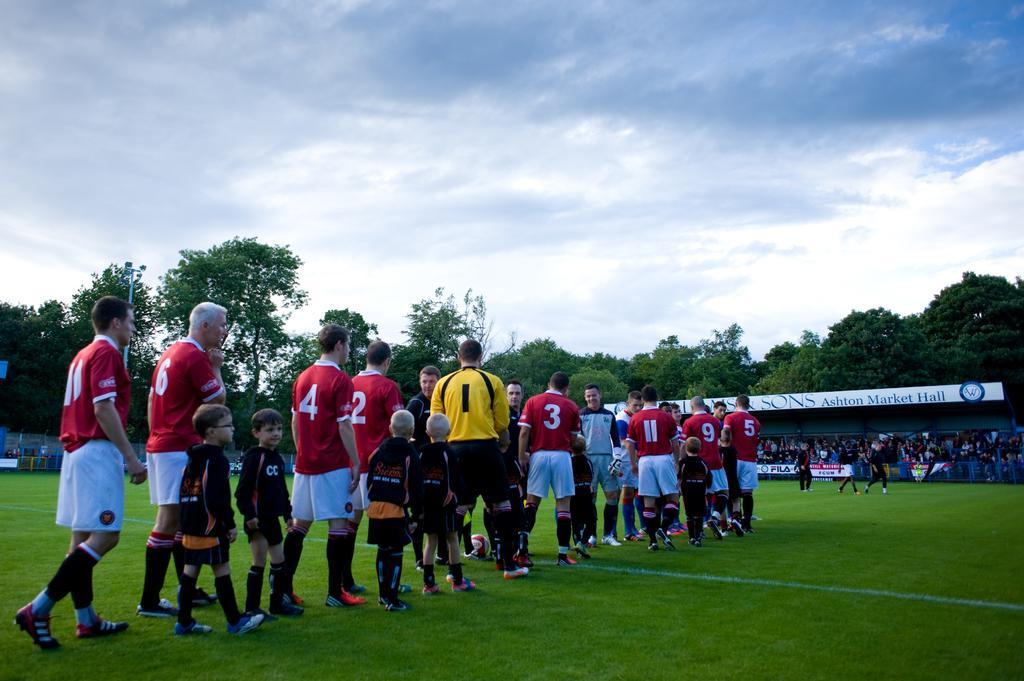How would you summarize this image in a sentence or two? Here we can see group of people on the ground. This is grass. In the background we can see trees, boards, group of people, and sky. 